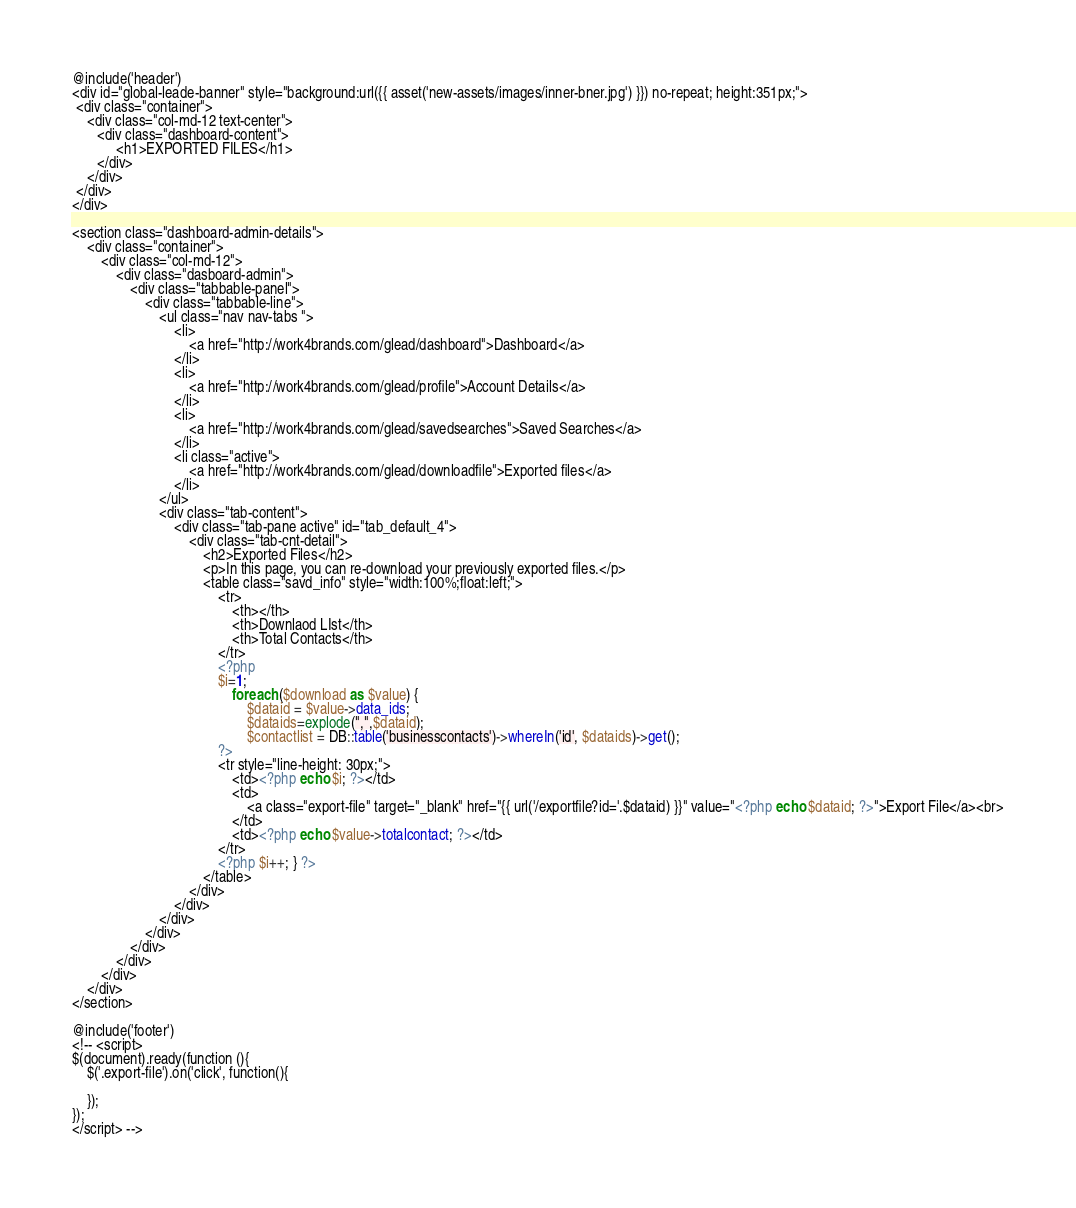Convert code to text. <code><loc_0><loc_0><loc_500><loc_500><_PHP_>@include('header')
<div id="global-leade-banner" style="background:url({{ asset('new-assets/images/inner-bner.jpg') }}) no-repeat; height:351px;">
 <div class="container">
    <div class="col-md-12 text-center">
	   <div class="dashboard-content">
	        <h1>EXPORTED FILES</h1>
	   </div>  
	</div>
 </div>
</div>  

<section class="dashboard-admin-details">
	<div class="container">
		<div class="col-md-12">
			<div class="dasboard-admin">
				<div class="tabbable-panel">
					<div class="tabbable-line">
						<ul class="nav nav-tabs ">
							<li>
								<a href="http://work4brands.com/glead/dashboard">Dashboard</a>
							</li>
							<li>
								<a href="http://work4brands.com/glead/profile">Account Details</a>
						  	</li>
							<li>
						     	<a href="http://work4brands.com/glead/savedsearches">Saved Searches</a>
							</li>
							<li class="active">
						     	<a href="http://work4brands.com/glead/downloadfile">Exported files</a>
							</li>
						</ul>
						<div class="tab-content">
							<div class="tab-pane active" id="tab_default_4">
								<div class="tab-cnt-detail">
									<h2>Exported Files</h2>
									<p>In this page, you can re-download your previously exported files.</p>
									<table class="savd_info" style="width:100%;float:left;">
										<tr>
											<th></th>
											<th>Downlaod LIst</th>
											<th>Total Contacts</th>
										</tr>
										<?php
										$i=1;
											foreach ($download as $value) {
												$dataid = $value->data_ids;
									            $dataids=explode(",",$dataid);
									            $contactlist = DB::table('businesscontacts')->whereIn('id', $dataids)->get();
									    ?>
										<tr style="line-height: 30px;">
											<td><?php echo $i; ?></td>
											<td>
									        	<a class="export-file" target="_blank" href="{{ url('/exportfile?id='.$dataid) }}" value="<?php echo $dataid; ?>">Export File</a><br>
											</td>
											<td><?php echo $value->totalcontact; ?></td>										
										</tr>
										<?php $i++; } ?>
									</table>
								</div>
							</div>
						</div>
					</div>
				</div>
			</div>
		</div>
	</div>
</section> 

@include('footer')
<!-- <script>
$(document).ready(function (){
	$('.export-file').on('click', function(){

	});
});
</script> --></code> 